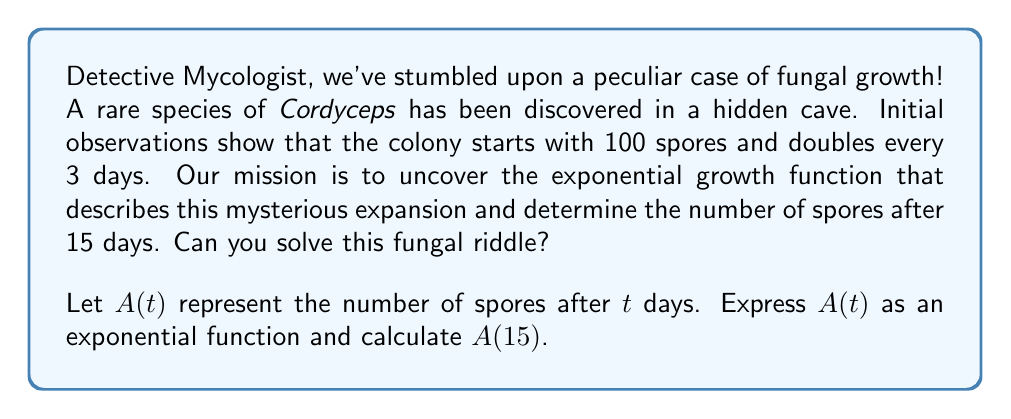What is the answer to this math problem? Let's approach this fungal mystery step by step, Detective Mycologist!

1) First, we need to identify the key elements of our exponential function:
   - Initial value (A₀): 100 spores
   - Growth factor: doubles (×2) every 3 days
   - Time variable: t (in days)

2) The general form of an exponential function is:
   $$ A(t) = A_0 \cdot b^{t/k} $$
   where A₀ is the initial value, b is the growth factor per unit time, and k is the time interval for each growth factor application.

3) In our case:
   A₀ = 100
   b = 2 (doubles)
   k = 3 (every 3 days)

4) Substituting these values into our exponential function:
   $$ A(t) = 100 \cdot 2^{t/3} $$

5) This is our growth function! Now, to find the number of spores after 15 days, we simply need to calculate A(15):
   $$ A(15) = 100 \cdot 2^{15/3} = 100 \cdot 2^5 = 100 \cdot 32 = 3200 $$

Thus, after 15 days, our Cordyceps colony will have grown to 3200 spores.
Answer: The exponential growth function is $A(t) = 100 \cdot 2^{t/3}$, and after 15 days, there will be 3200 spores. 